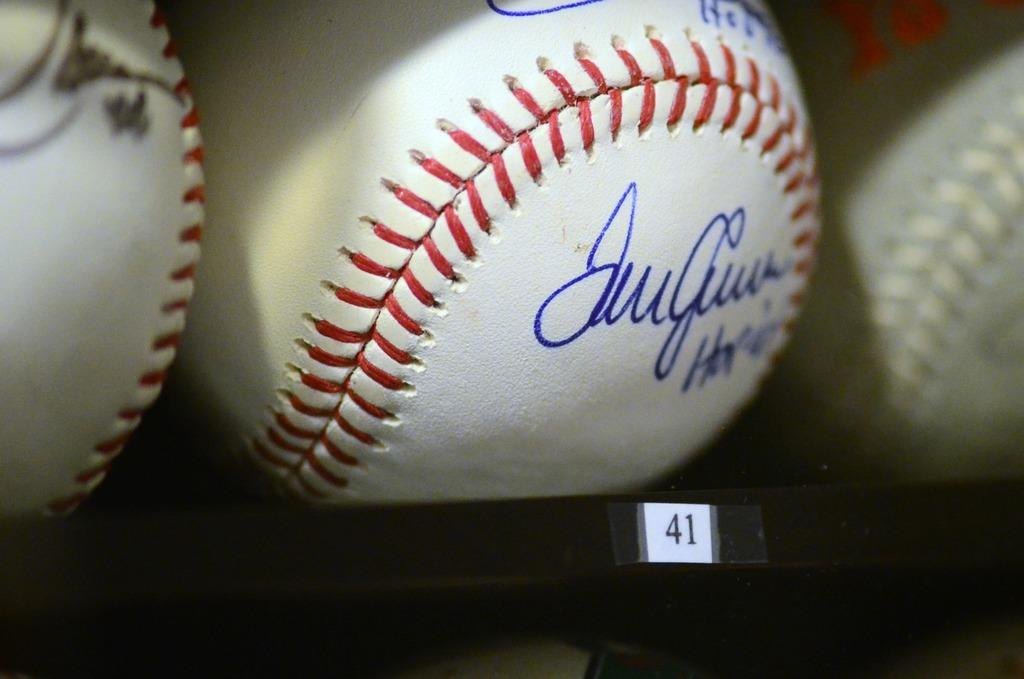<image>
Relay a brief, clear account of the picture shown. A signed baseball on position 41 of a shelf next to several other baseballs. 